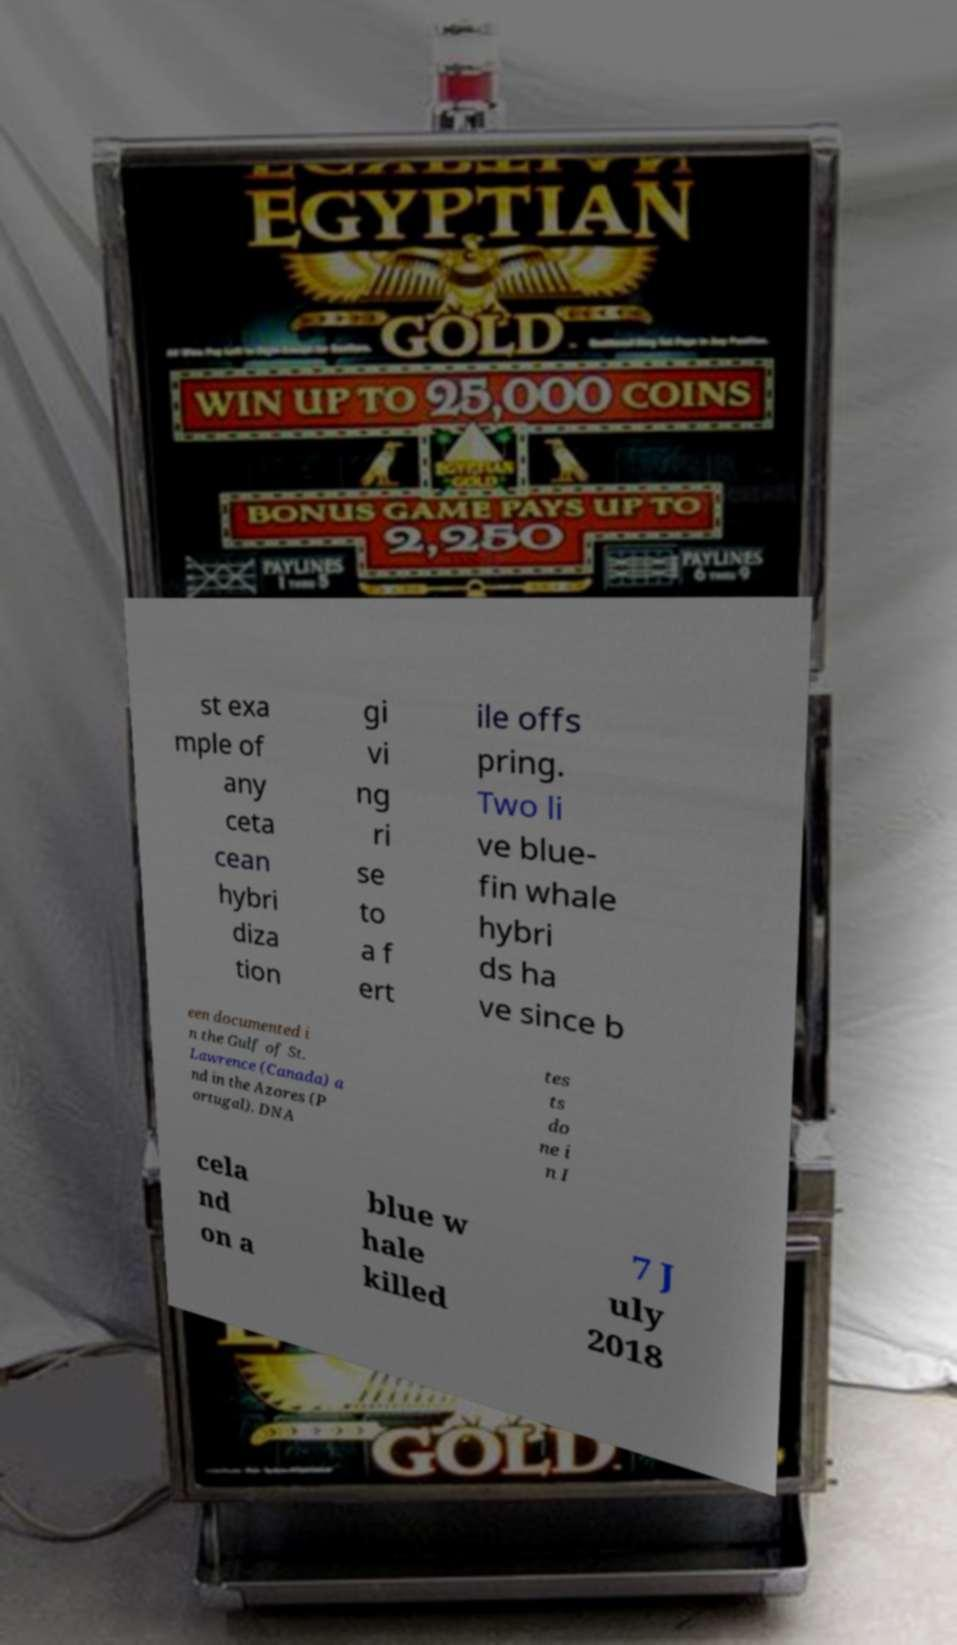Can you accurately transcribe the text from the provided image for me? st exa mple of any ceta cean hybri diza tion gi vi ng ri se to a f ert ile offs pring. Two li ve blue- fin whale hybri ds ha ve since b een documented i n the Gulf of St. Lawrence (Canada) a nd in the Azores (P ortugal). DNA tes ts do ne i n I cela nd on a blue w hale killed 7 J uly 2018 